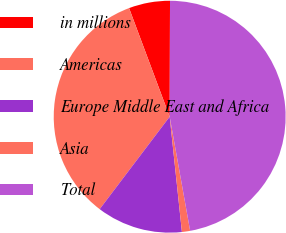Convert chart. <chart><loc_0><loc_0><loc_500><loc_500><pie_chart><fcel>in millions<fcel>Americas<fcel>Europe Middle East and Africa<fcel>Asia<fcel>Total<nl><fcel>5.74%<fcel>33.99%<fcel>12.0%<fcel>1.14%<fcel>47.13%<nl></chart> 